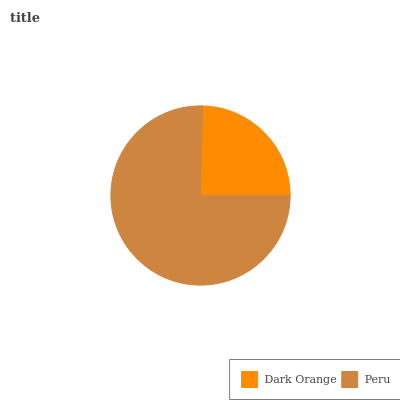Is Dark Orange the minimum?
Answer yes or no. Yes. Is Peru the maximum?
Answer yes or no. Yes. Is Peru the minimum?
Answer yes or no. No. Is Peru greater than Dark Orange?
Answer yes or no. Yes. Is Dark Orange less than Peru?
Answer yes or no. Yes. Is Dark Orange greater than Peru?
Answer yes or no. No. Is Peru less than Dark Orange?
Answer yes or no. No. Is Peru the high median?
Answer yes or no. Yes. Is Dark Orange the low median?
Answer yes or no. Yes. Is Dark Orange the high median?
Answer yes or no. No. Is Peru the low median?
Answer yes or no. No. 